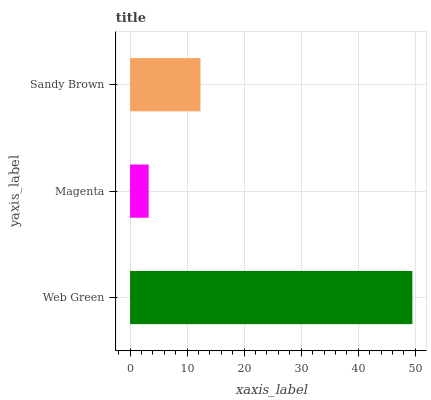Is Magenta the minimum?
Answer yes or no. Yes. Is Web Green the maximum?
Answer yes or no. Yes. Is Sandy Brown the minimum?
Answer yes or no. No. Is Sandy Brown the maximum?
Answer yes or no. No. Is Sandy Brown greater than Magenta?
Answer yes or no. Yes. Is Magenta less than Sandy Brown?
Answer yes or no. Yes. Is Magenta greater than Sandy Brown?
Answer yes or no. No. Is Sandy Brown less than Magenta?
Answer yes or no. No. Is Sandy Brown the high median?
Answer yes or no. Yes. Is Sandy Brown the low median?
Answer yes or no. Yes. Is Magenta the high median?
Answer yes or no. No. Is Magenta the low median?
Answer yes or no. No. 